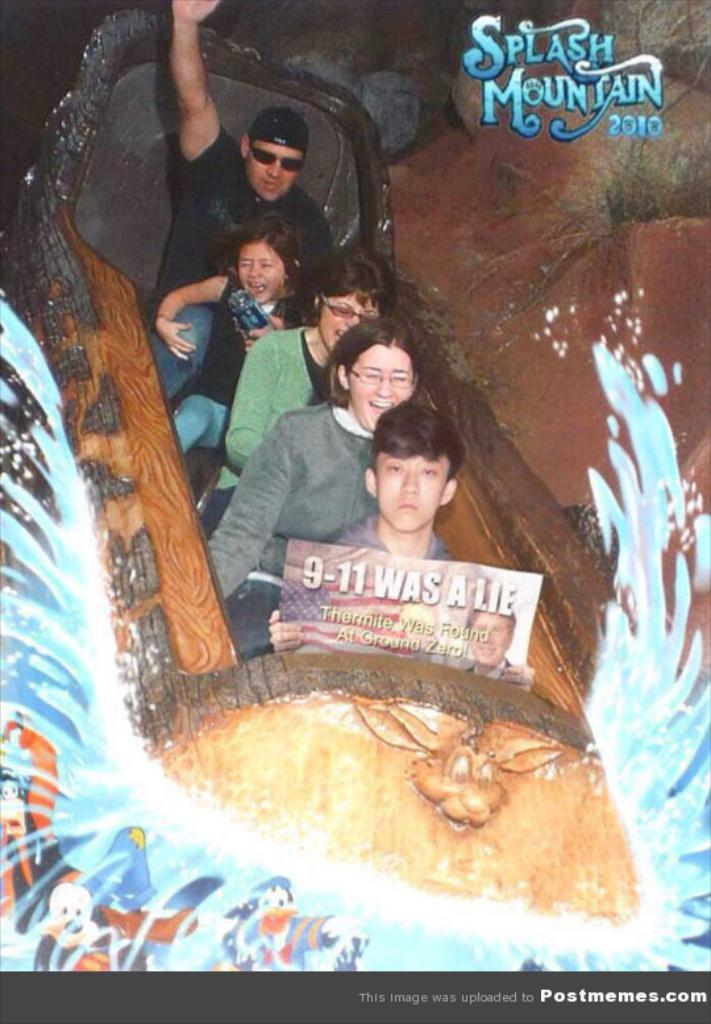What is present in the image that contains visual information? There is a poster in the image. What type of images can be seen on the poster? The poster contains images of people. Is there any text present on the poster? Yes, there is text on the poster. How far away is the gate from the poster in the image? There is no gate present in the image, so it is not possible to determine the distance between the poster and a gate. 